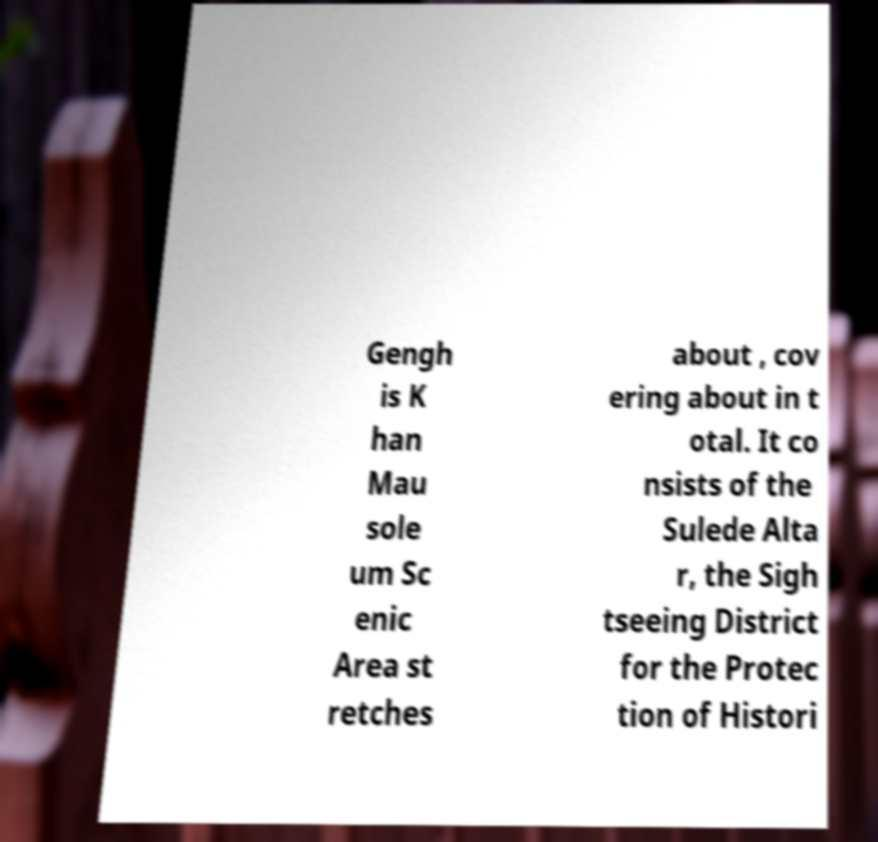Please read and relay the text visible in this image. What does it say? Gengh is K han Mau sole um Sc enic Area st retches about , cov ering about in t otal. It co nsists of the Sulede Alta r, the Sigh tseeing District for the Protec tion of Histori 